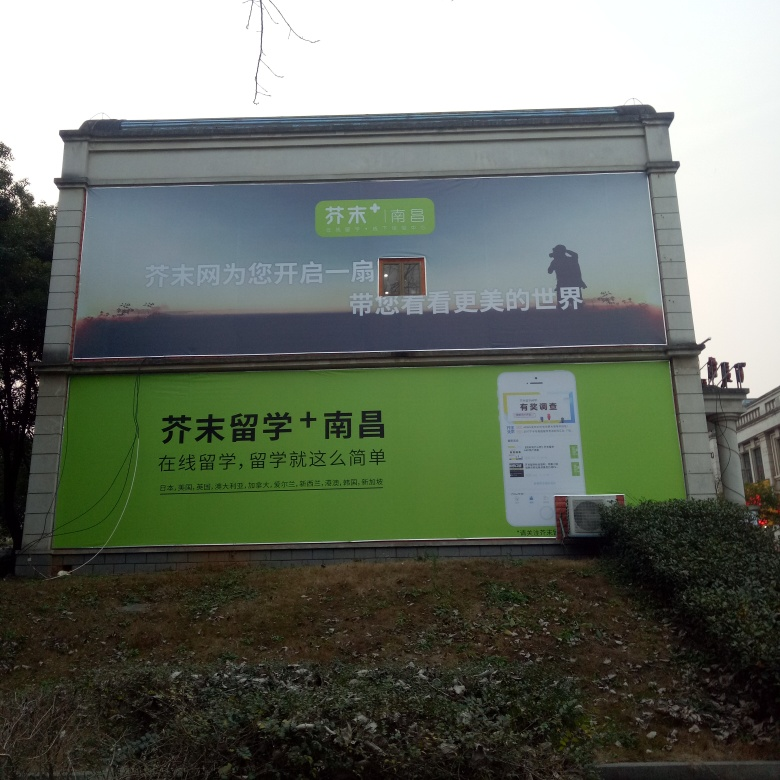Is there anything in the image that suggests when the photo was taken or the billboard's location? Based on the language and characters on the billboard, it suggests that the photo was taken in a Chinese-speaking region. The specific time when the photo was taken is more challenging to determine, but the clothing of the silhouette suggests cooler weather, and the overcast sky could imply a season with more cloud cover. 